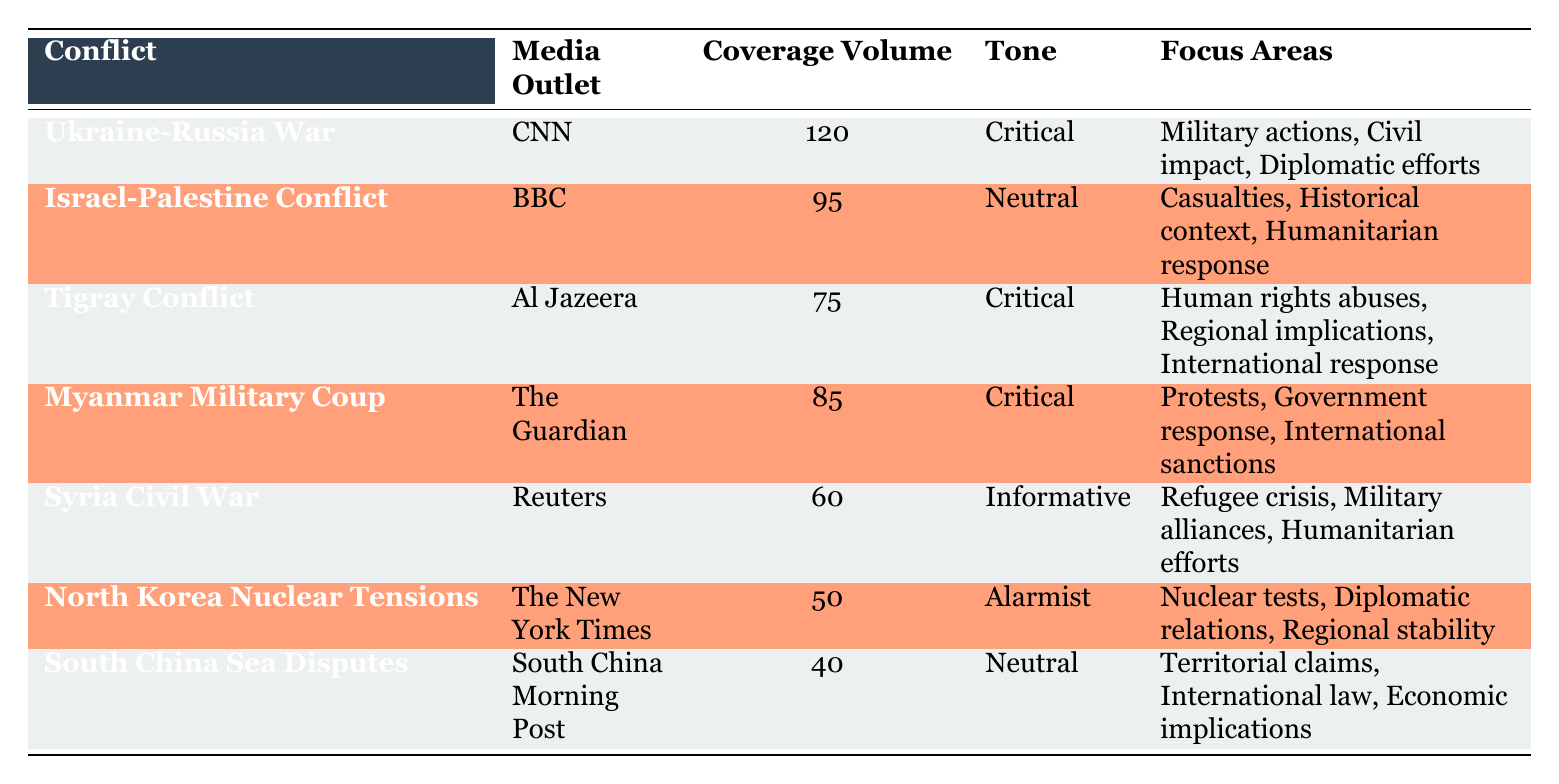What is the coverage volume for the Ukraine-Russia War? According to the table, the "Coverage Volume" for the "Ukraine-Russia War" listed under CNN is 120.
Answer: 120 Which media outlet covered the Syria Civil War? The table specifies that the "Syria Civil War" is covered by "Reuters."
Answer: Reuters What is the tone of the coverage for the Tigray Conflict? The table indicates that the "Tigray Conflict" is associated with a "Critical" tone according to Al Jazeera.
Answer: Critical How many conflicts have a coverage volume greater than 70? By examining the coverage volumes, both the Ukraine-Russia War (120) and the Israel-Palestine Conflict (95) are over 70, so there are four conflicts above that threshold: Ukraine-Russia War, Israel-Palestine Conflict, Tigray Conflict, and Myanmar Military Coup.
Answer: 4 Is the coverage tone for North Korea Nuclear Tensions informative? The table shows that the tone of coverage for "North Korea Nuclear Tensions" is categorized as "Alarmist," thus the statement is false.
Answer: No What is the average coverage volume for the conflicts listed? To find the average, we sum the coverage volumes: 120 + 95 + 75 + 85 + 60 + 50 + 40 = 525. As there are seven conflicts, dividing the total by 7 gives us an average of 525/7 = 75.
Answer: 75 Which conflict has the lowest coverage volume? The table shows that the "South China Sea Disputes" has the lowest coverage volume at 40, as it is the smallest value listed under "Coverage Volume."
Answer: South China Sea Disputes Identify the number of critical tone reports in the table. The table mentions three critical reports: Ukraine-Russia War, Tigray Conflict, and Myanmar Military Coup. Counting them yields a total of three conflicts with critical coverage.
Answer: 3 Which conflict has the highest coverage volume and what is its tone? The "Ukraine-Russia War" has the highest coverage volume at 120, and the tone is described as "Critical," based on the information in the table.
Answer: Ukraine-Russia War, Critical 